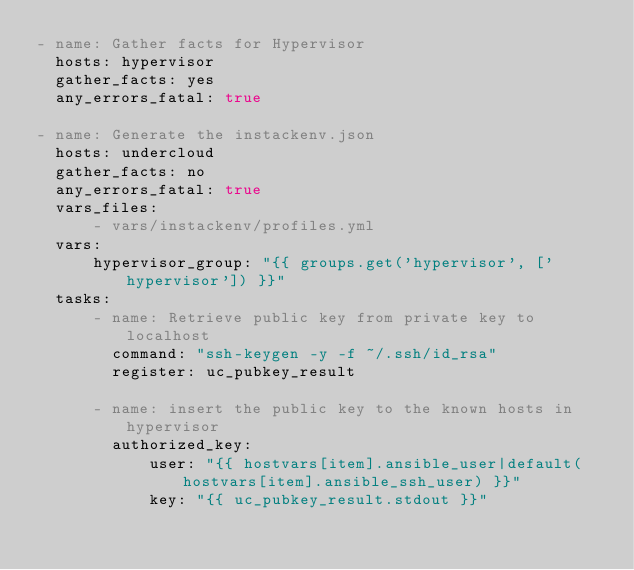<code> <loc_0><loc_0><loc_500><loc_500><_YAML_>- name: Gather facts for Hypervisor
  hosts: hypervisor
  gather_facts: yes
  any_errors_fatal: true

- name: Generate the instackenv.json
  hosts: undercloud
  gather_facts: no
  any_errors_fatal: true
  vars_files:
      - vars/instackenv/profiles.yml
  vars:
      hypervisor_group: "{{ groups.get('hypervisor', ['hypervisor']) }}"
  tasks:
      - name: Retrieve public key from private key to localhost
        command: "ssh-keygen -y -f ~/.ssh/id_rsa"
        register: uc_pubkey_result

      - name: insert the public key to the known hosts in hypervisor
        authorized_key:
            user: "{{ hostvars[item].ansible_user|default(hostvars[item].ansible_ssh_user) }}"
            key: "{{ uc_pubkey_result.stdout }}"</code> 